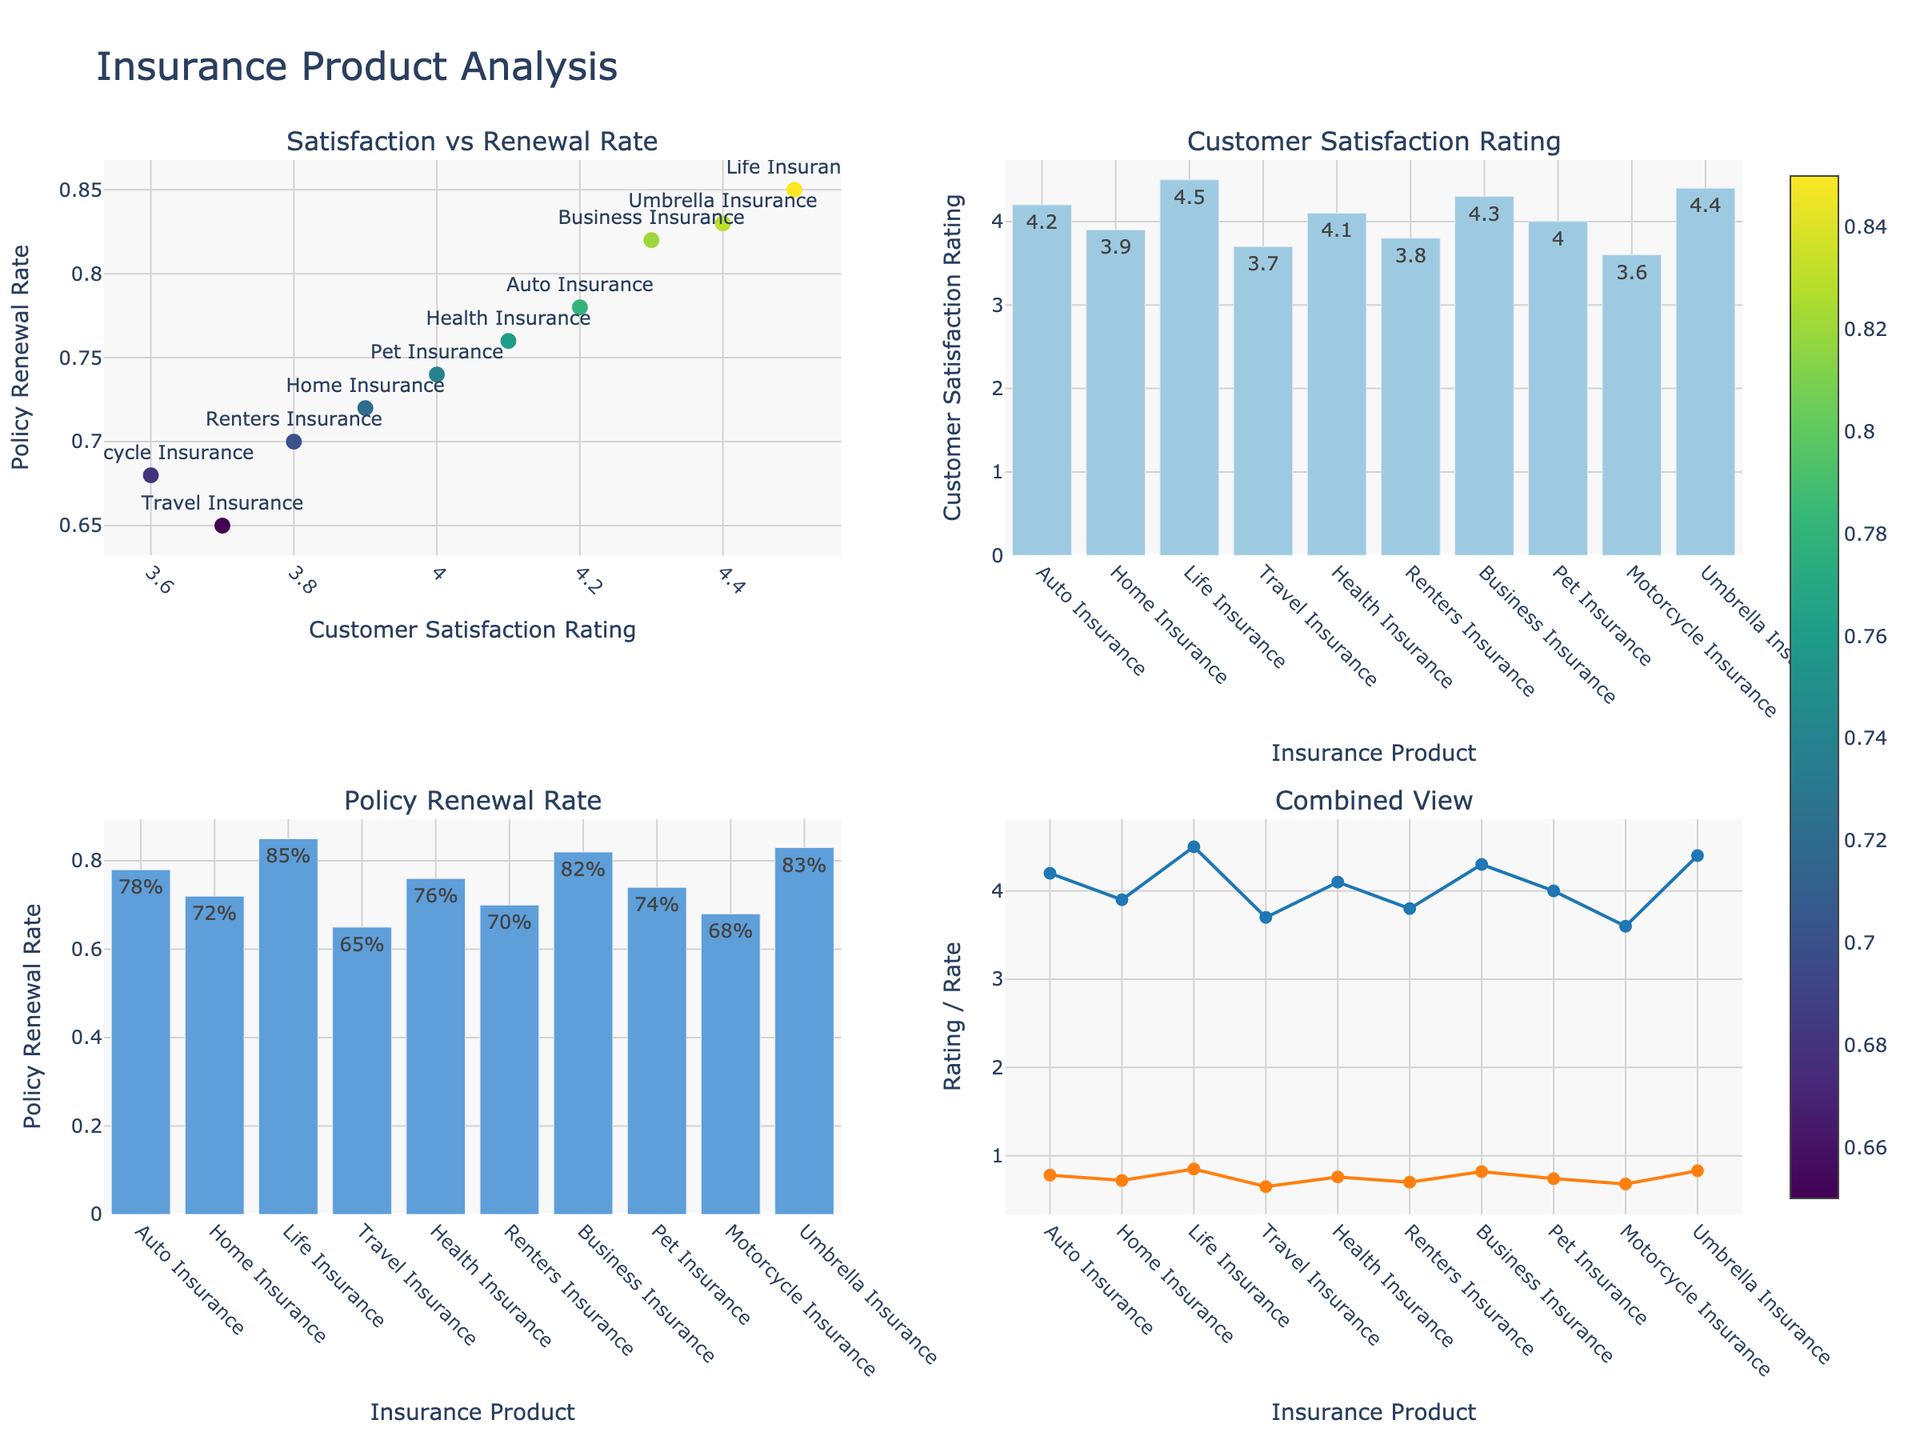How does the customer satisfaction rating for "Auto Insurance" compare to "Home Insurance"? "Auto Insurance" has a customer satisfaction rating of 4.2, while "Home Insurance" has a rating of 3.9. We can directly compare these two numbers.
Answer: Auto Insurance has a higher rating What is the average policy renewal rate across all insurance products? To find the average, sum up all the policy renewal rates and divide by the number of products. The rates to sum are: 0.78, 0.72, 0.85, 0.65, 0.76, 0.70, 0.82, 0.74, 0.68, 0.83. The sum is 7.53. There are 10 products, so the average is 7.53 / 10 = 0.753.
Answer: 0.753 Which insurance product has the highest customer satisfaction rating? By looking at the bar chart for "Customer Satisfaction Rating", the tallest bar corresponds to "Life Insurance" with a rating of 4.5.
Answer: Life Insurance Is there a visible trend between customer satisfaction ratings and policy renewal rates? By observing the scatter plot of "Satisfaction vs Renewal Rate", the general trend shows higher customer satisfaction ratings tend to be associated with higher policy renewal rates. This can be seen from the upward pattern of the scatter points.
Answer: Yes, a positive trend How do the policy renewal rates of "Health Insurance" and "Travel Insurance" compare? "Health Insurance" has a policy renewal rate of 0.76, and "Travel Insurance" has a rate of 0.65. We compare these two numbers directly.
Answer: Health Insurance has a higher renewal rate Which insurance product has the lowest customer satisfaction rating? By examining the bar chart for "Customer Satisfaction Rating", the shortest bar corresponds to "Motorcycle Insurance" with a rating of 3.6.
Answer: Motorcycle Insurance What is the difference in policy renewal rates between "Life Insurance" and "Renters Insurance"? "Life Insurance" has a policy renewal rate of 0.85, while "Renters Insurance" has a rate of 0.70. The difference is calculated as 0.85 - 0.70.
Answer: 0.15 How many insurance products have a customer satisfaction rating above 4.0? By observing the bar chart for "Customer Satisfaction Rating", count the number of bars that are taller than the 4.0 mark. There are 6 products: Auto Insurance, Life Insurance, Health Insurance, Business Insurance, Pet Insurance, and Umbrella Insurance.
Answer: 6 What is the policy renewal rate for "Pet Insurance"? By looking at the bar chart for "Policy Renewal Rate", "Pet Insurance" has a renewal rate, which can be found using its hover text. The rate is 0.74.
Answer: 0.74 Which insurance product has the highest policy renewal rate? In the bar chart for "Policy Renewal Rate", the tallest bar represents "Life Insurance" with a renewal rate of 0.85.
Answer: Life Insurance 